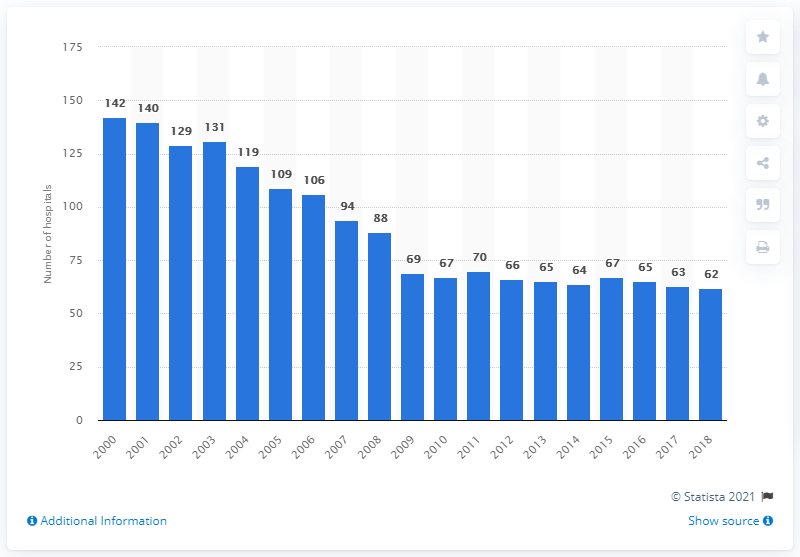Point out several critical features in this image. In 2018, there were 62 hospitals in Latvia. In 2000, there were 142 hospitals in Latvia. 